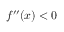<formula> <loc_0><loc_0><loc_500><loc_500>f ^ { \prime \prime } ( x ) < 0</formula> 